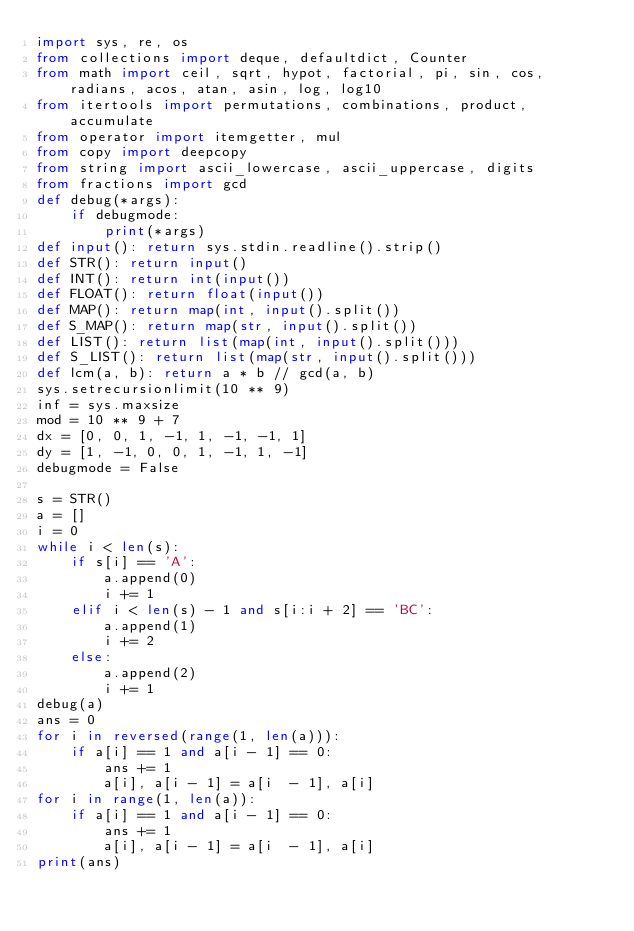Convert code to text. <code><loc_0><loc_0><loc_500><loc_500><_Python_>import sys, re, os
from collections import deque, defaultdict, Counter
from math import ceil, sqrt, hypot, factorial, pi, sin, cos, radians, acos, atan, asin, log, log10
from itertools import permutations, combinations, product, accumulate
from operator import itemgetter, mul
from copy import deepcopy
from string import ascii_lowercase, ascii_uppercase, digits
from fractions import gcd
def debug(*args):
    if debugmode:
        print(*args)
def input(): return sys.stdin.readline().strip()
def STR(): return input()
def INT(): return int(input())
def FLOAT(): return float(input())
def MAP(): return map(int, input().split())
def S_MAP(): return map(str, input().split())
def LIST(): return list(map(int, input().split()))
def S_LIST(): return list(map(str, input().split()))
def lcm(a, b): return a * b // gcd(a, b)
sys.setrecursionlimit(10 ** 9)
inf = sys.maxsize
mod = 10 ** 9 + 7
dx = [0, 0, 1, -1, 1, -1, -1, 1]
dy = [1, -1, 0, 0, 1, -1, 1, -1]
debugmode = False

s = STR()
a = []
i = 0
while i < len(s):
    if s[i] == 'A':
        a.append(0)
        i += 1
    elif i < len(s) - 1 and s[i:i + 2] == 'BC':
        a.append(1)
        i += 2
    else:
        a.append(2)
        i += 1
debug(a)
ans = 0
for i in reversed(range(1, len(a))):
    if a[i] == 1 and a[i - 1] == 0:
        ans += 1
        a[i], a[i - 1] = a[i  - 1], a[i]
for i in range(1, len(a)):
    if a[i] == 1 and a[i - 1] == 0:
        ans += 1
        a[i], a[i - 1] = a[i  - 1], a[i]
print(ans)</code> 